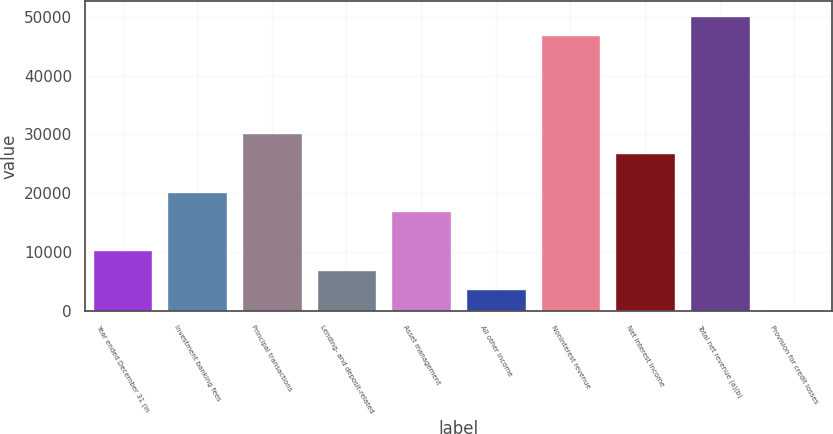Convert chart. <chart><loc_0><loc_0><loc_500><loc_500><bar_chart><fcel>Year ended December 31 (in<fcel>Investment banking fees<fcel>Principal transactions<fcel>Lending- and deposit-related<fcel>Asset management<fcel>All other income<fcel>Noninterest revenue<fcel>Net interest income<fcel>Total net revenue (a)(b)<fcel>Provision for credit losses<nl><fcel>10295<fcel>20258<fcel>30221<fcel>6974<fcel>16937<fcel>3653<fcel>46826<fcel>26900<fcel>50147<fcel>332<nl></chart> 